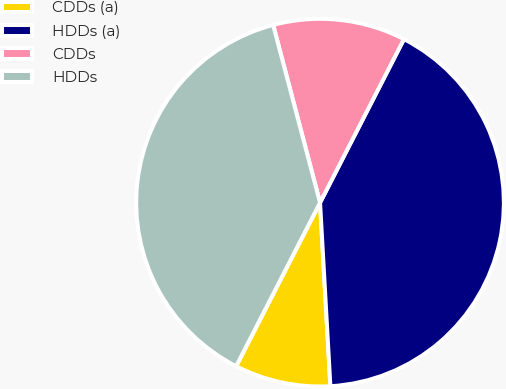Convert chart to OTSL. <chart><loc_0><loc_0><loc_500><loc_500><pie_chart><fcel>CDDs (a)<fcel>HDDs (a)<fcel>CDDs<fcel>HDDs<nl><fcel>8.44%<fcel>41.56%<fcel>11.65%<fcel>38.35%<nl></chart> 